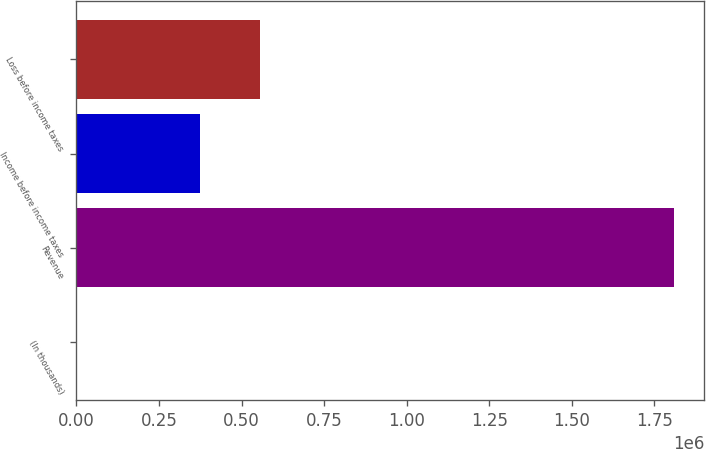<chart> <loc_0><loc_0><loc_500><loc_500><bar_chart><fcel>(In thousands)<fcel>Revenue<fcel>Income before income taxes<fcel>Loss before income taxes<nl><fcel>2008<fcel>1.81081e+06<fcel>374738<fcel>555618<nl></chart> 